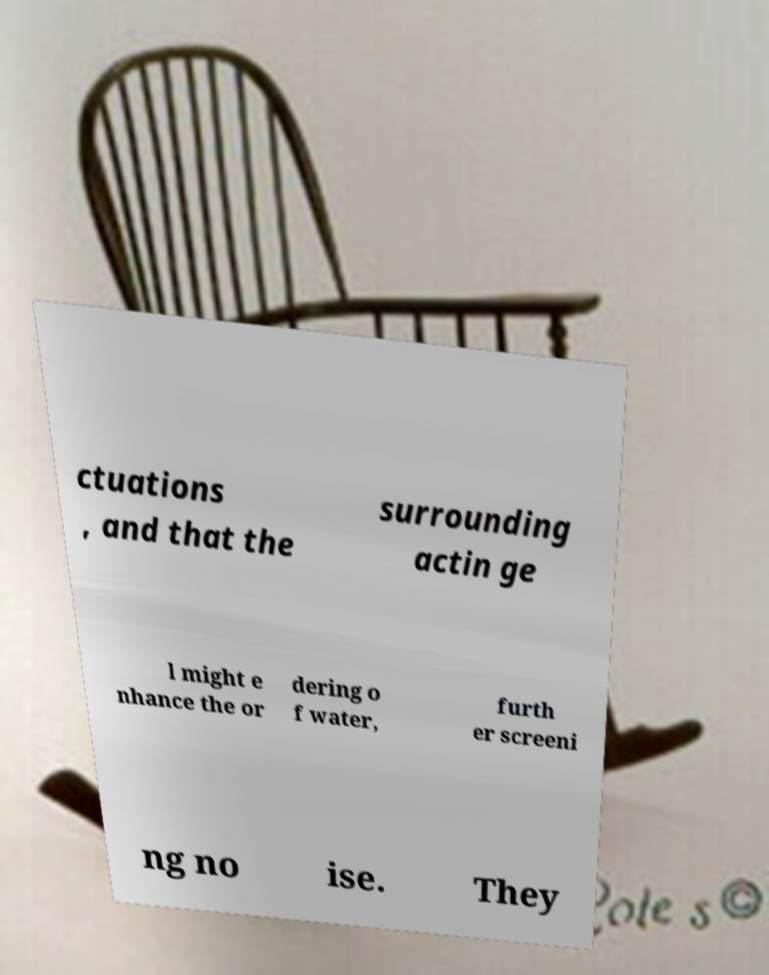Could you assist in decoding the text presented in this image and type it out clearly? ctuations , and that the surrounding actin ge l might e nhance the or dering o f water, furth er screeni ng no ise. They 